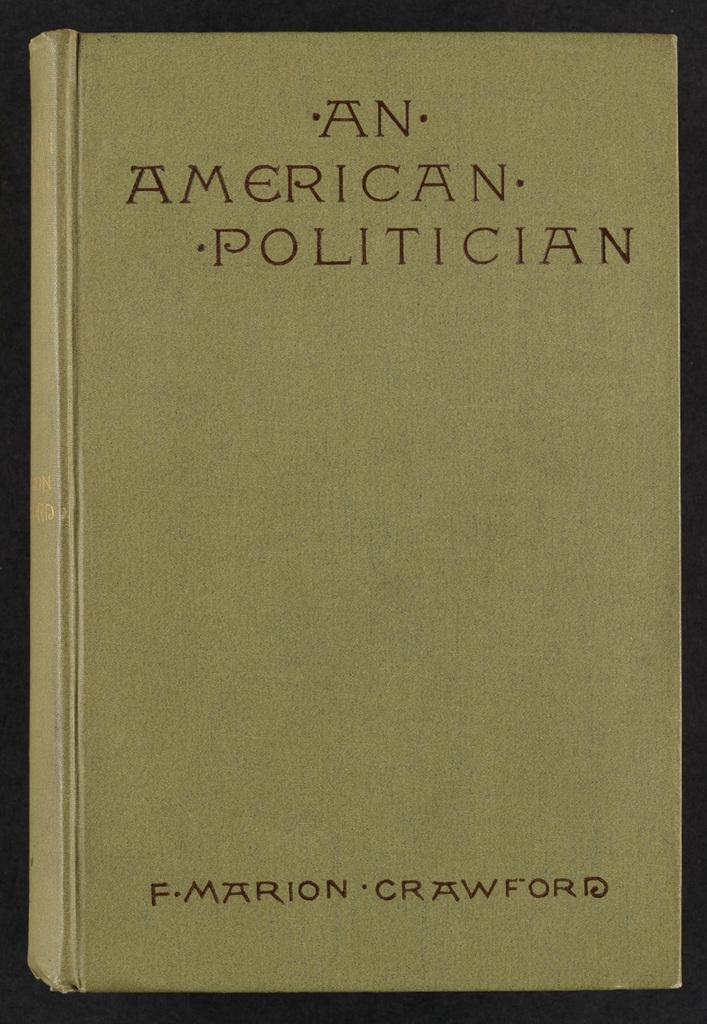<image>
Share a concise interpretation of the image provided. A book titles An American Politician has a plain front cover. 